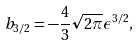<formula> <loc_0><loc_0><loc_500><loc_500>b _ { 3 / 2 } = - \frac { 4 } { 3 } \sqrt { 2 \pi } \epsilon ^ { 3 / 2 } ,</formula> 